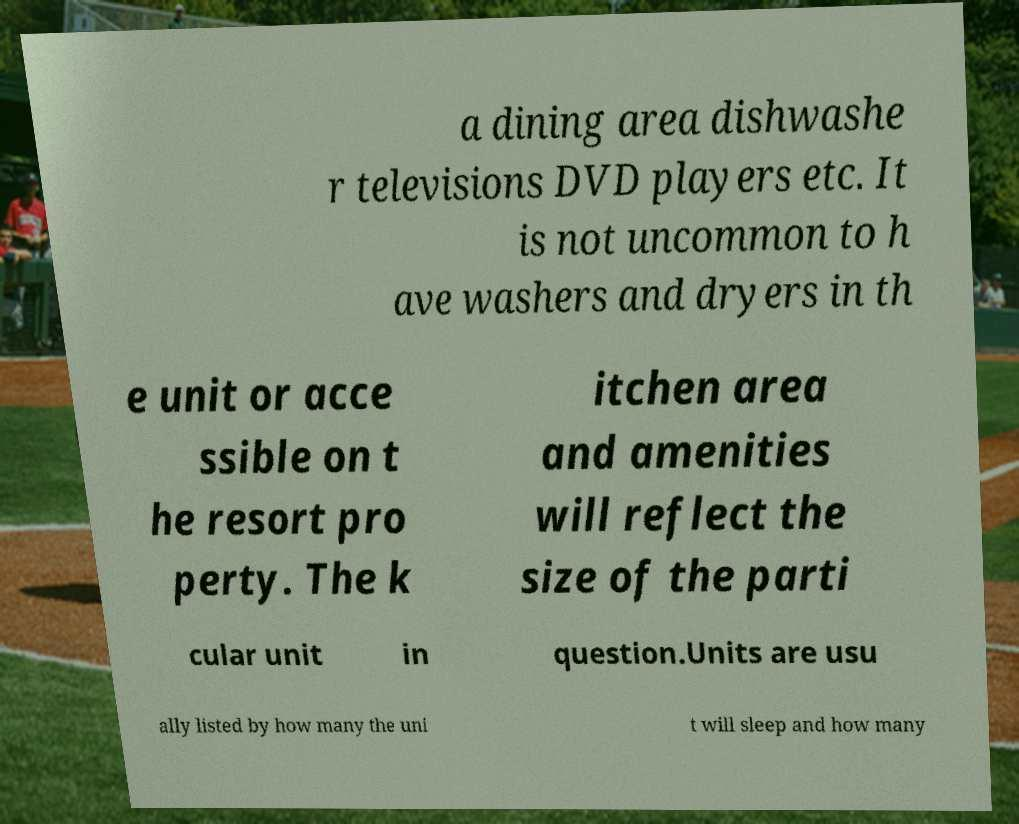Can you read and provide the text displayed in the image?This photo seems to have some interesting text. Can you extract and type it out for me? a dining area dishwashe r televisions DVD players etc. It is not uncommon to h ave washers and dryers in th e unit or acce ssible on t he resort pro perty. The k itchen area and amenities will reflect the size of the parti cular unit in question.Units are usu ally listed by how many the uni t will sleep and how many 